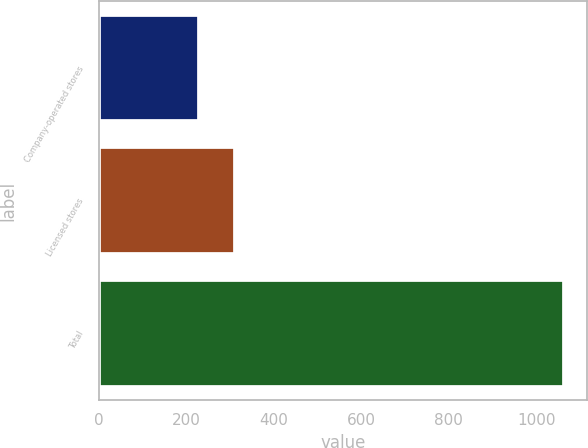Convert chart to OTSL. <chart><loc_0><loc_0><loc_500><loc_500><bar_chart><fcel>Company-operated stores<fcel>Licensed stores<fcel>Total<nl><fcel>228<fcel>311.5<fcel>1063<nl></chart> 